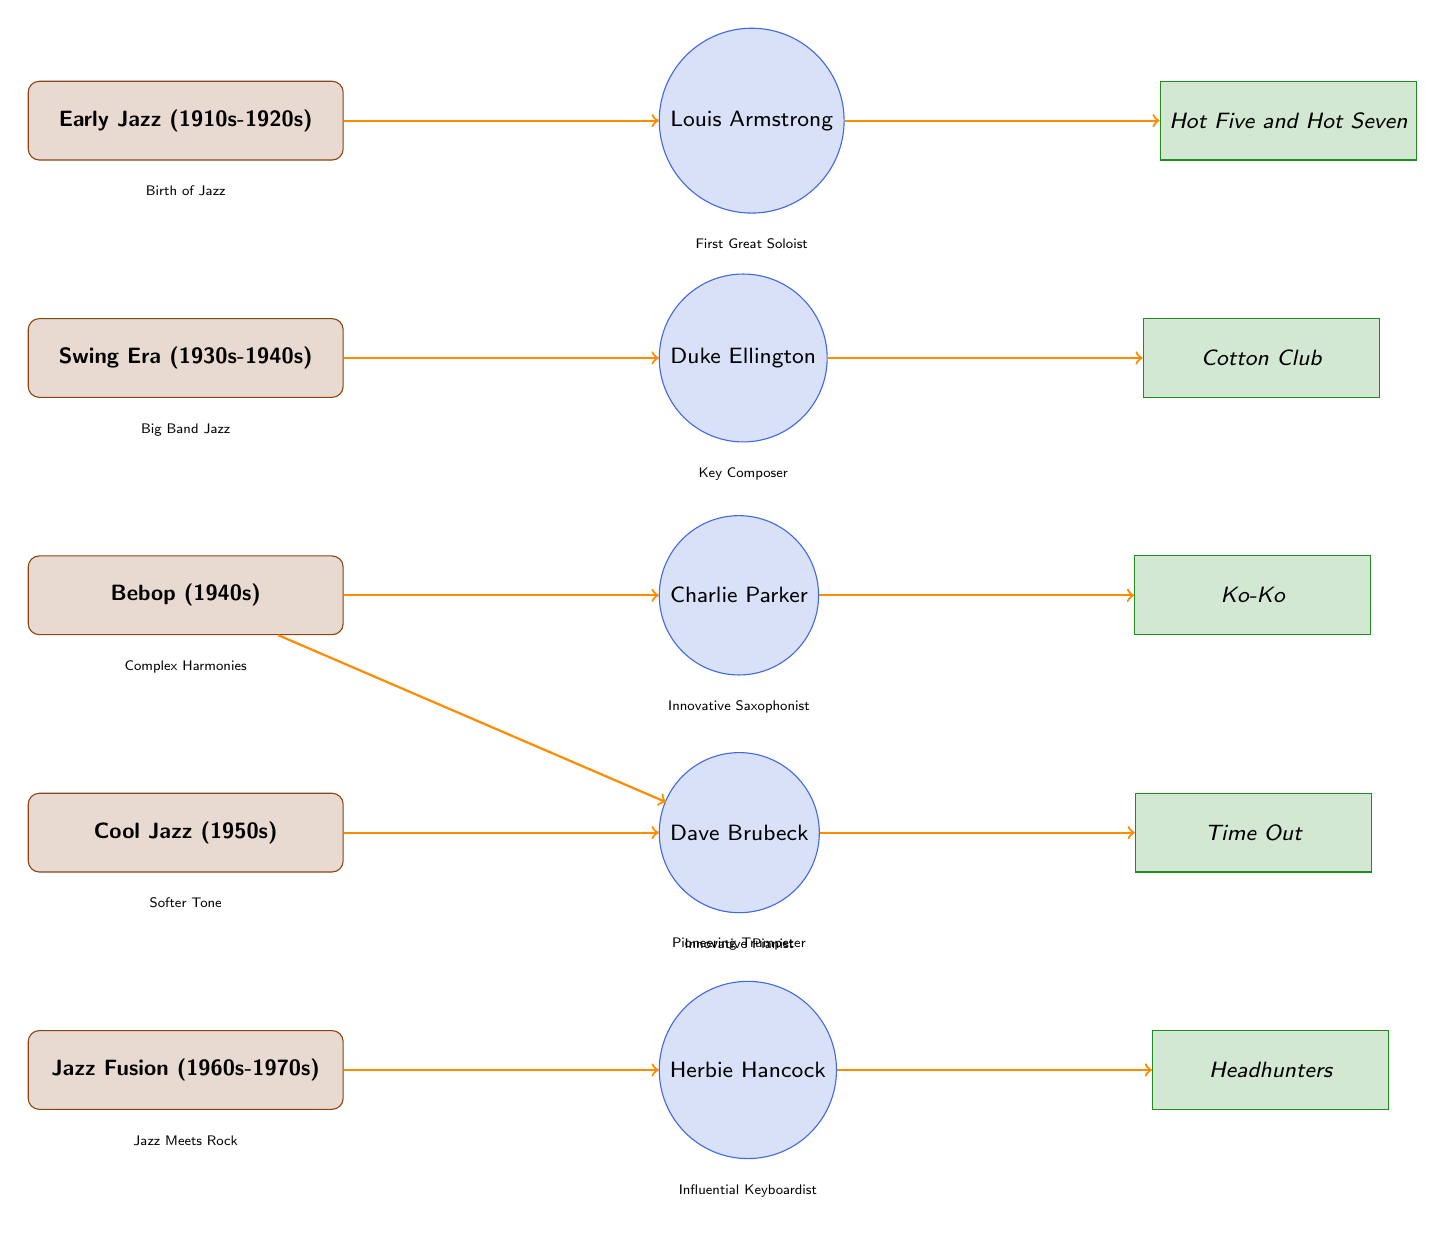What is the first era of Jazz shown in the diagram? The diagram indicates the first era of Jazz at the top, labeled as "Early Jazz (1910s-1920s)." This can be located by observing the vertical arrangement of eras in the diagram.
Answer: Early Jazz (1910s-1920s) Who is the key artist associated with the Swing Era? The Swing Era in the diagram is represented directly above the artist node labeled "Duke Ellington," implying his significance to this period.
Answer: Duke Ellington What album is linked to Louis Armstrong? The connection from the artist node "Louis Armstrong" points directly to the album node "Hot Five and Hot Seven" in the diagram, showing their relationship.
Answer: Hot Five and Hot Seven How many key artists are listed in the diagram? Counting the circles representing key artists leads to five distinct artists: Louis Armstrong, Duke Ellington, Charlie Parker, Miles Davis, and Dave Brubeck, thus giving us the total.
Answer: 5 Which artist is known as an "Innovative Saxophonist"? The diagram designates "Charlie Parker" underneath the artist node with this descriptive label, indicating his role and contribution to jazz.
Answer: Charlie Parker Which jazz era is defined by complex harmonies? The label directly below the Bebop era node states "Complex Harmonies," which describes this particular time period in jazz history.
Answer: Bebop (1940s) Which artist is linked to Jazz Fusion? Looking at the bottom of the diagram, the label for Jazz Fusion points right to the artist "Herbie Hancock," establishing their connection.
Answer: Herbie Hancock What is the name of the influential album connected to Dave Brubeck? The artist node "Dave Brubeck" directs to the rectangular album node labeled "Time Out," which indicates its significance as linked to him.
Answer: Time Out What does the diagram say about the musical style of Cool Jazz? The description below the Cool Jazz node states "Softer Tone," which reflects the characteristic sound associated with this jazz style.
Answer: Softer Tone 